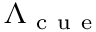<formula> <loc_0><loc_0><loc_500><loc_500>\Lambda _ { c u e }</formula> 